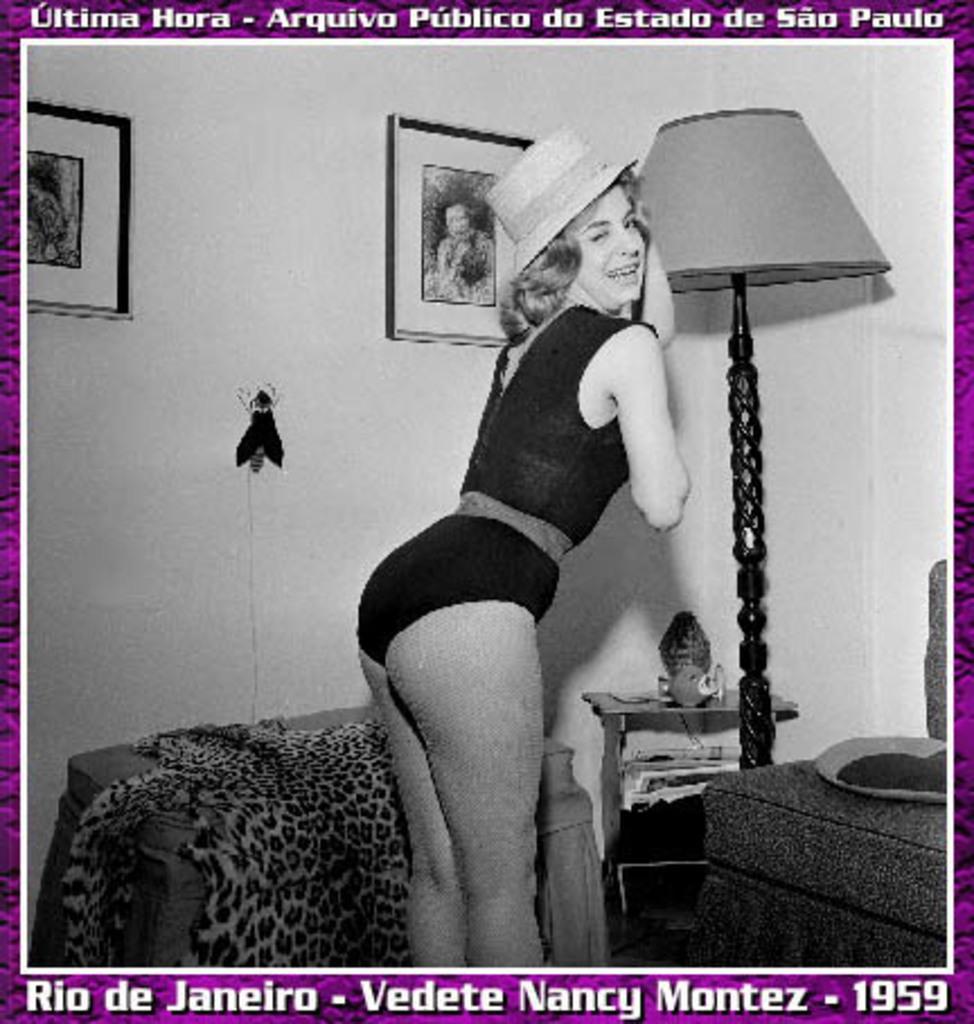Please provide a concise description of this image. In this image I can see a woman standing and wearing black color dress. Back I can see a lamp and some objects on the table. In front I can see couch and pillows. The frame is attached to the wall. The image is in black and white. 